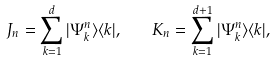Convert formula to latex. <formula><loc_0><loc_0><loc_500><loc_500>J _ { n } = \sum _ { k = 1 } ^ { d } | \Psi _ { k } ^ { n } \rangle \langle k | , \quad K _ { n } = \sum _ { k = 1 } ^ { { d } + 1 } | \Psi _ { k } ^ { n } \rangle \langle k | ,</formula> 